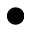<formula> <loc_0><loc_0><loc_500><loc_500>\bullet</formula> 